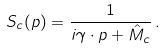Convert formula to latex. <formula><loc_0><loc_0><loc_500><loc_500>S _ { c } ( p ) = \frac { 1 } { i \gamma \cdot p + \hat { M } _ { c } } \, .</formula> 